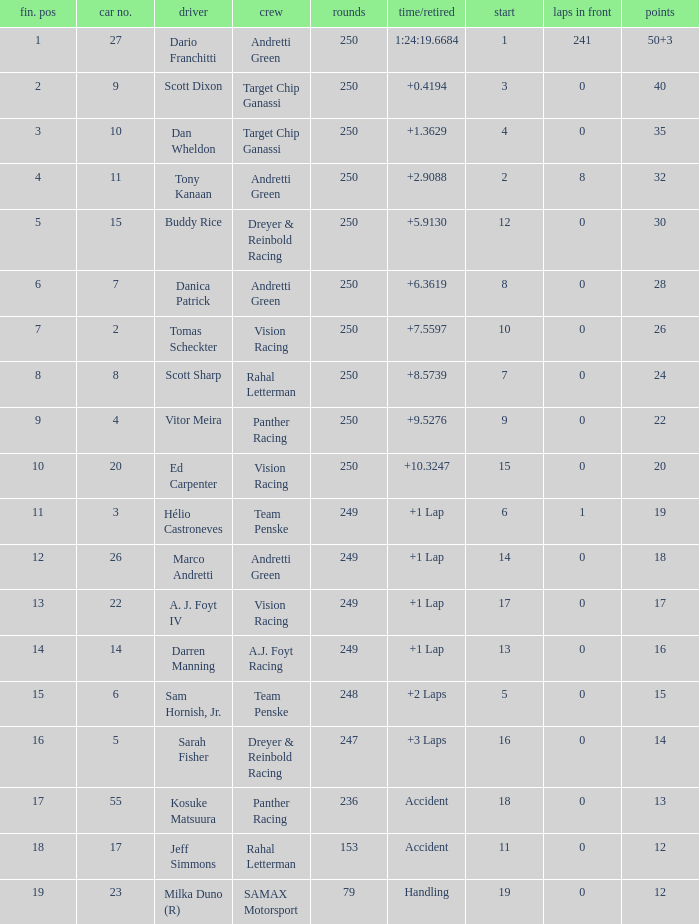Name the total number of fin pos for 12 points of accident 1.0. 